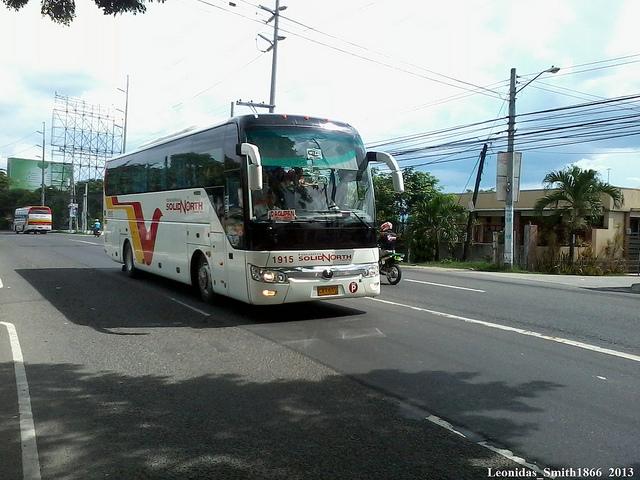What is making the shadow in front of the bus?
Be succinct. Tree. Is the sidewalk empty?
Give a very brief answer. Yes. Is this bus moving?
Write a very short answer. Yes. How many buses are there?
Answer briefly. 2. What kind of tree is on the corner?
Be succinct. Palm. 